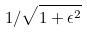<formula> <loc_0><loc_0><loc_500><loc_500>1 / \sqrt { 1 + \epsilon ^ { 2 } }</formula> 